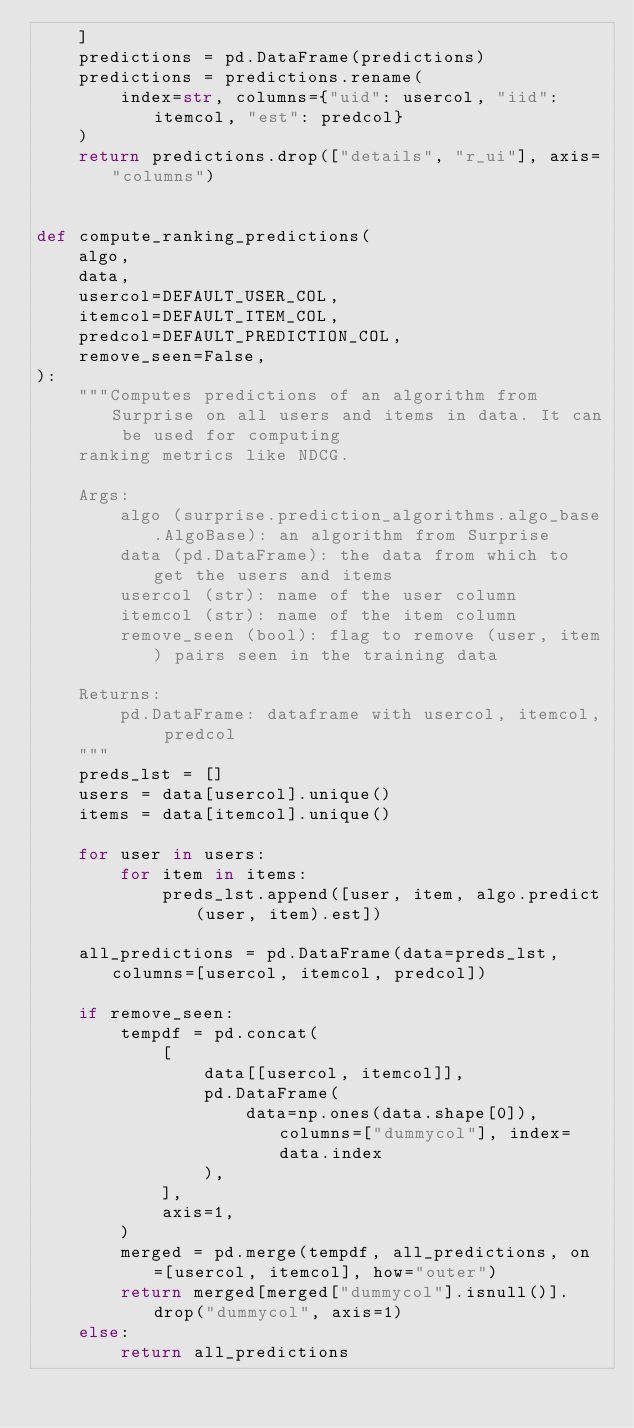Convert code to text. <code><loc_0><loc_0><loc_500><loc_500><_Python_>    ]
    predictions = pd.DataFrame(predictions)
    predictions = predictions.rename(
        index=str, columns={"uid": usercol, "iid": itemcol, "est": predcol}
    )
    return predictions.drop(["details", "r_ui"], axis="columns")


def compute_ranking_predictions(
    algo,
    data,
    usercol=DEFAULT_USER_COL,
    itemcol=DEFAULT_ITEM_COL,
    predcol=DEFAULT_PREDICTION_COL,
    remove_seen=False,
):
    """Computes predictions of an algorithm from Surprise on all users and items in data. It can be used for computing
    ranking metrics like NDCG.
    
    Args:
        algo (surprise.prediction_algorithms.algo_base.AlgoBase): an algorithm from Surprise
        data (pd.DataFrame): the data from which to get the users and items
        usercol (str): name of the user column
        itemcol (str): name of the item column
        remove_seen (bool): flag to remove (user, item) pairs seen in the training data
    
    Returns:
        pd.DataFrame: dataframe with usercol, itemcol, predcol
    """
    preds_lst = []
    users = data[usercol].unique()
    items = data[itemcol].unique()

    for user in users:
        for item in items:
            preds_lst.append([user, item, algo.predict(user, item).est])

    all_predictions = pd.DataFrame(data=preds_lst, columns=[usercol, itemcol, predcol])

    if remove_seen:
        tempdf = pd.concat(
            [
                data[[usercol, itemcol]],
                pd.DataFrame(
                    data=np.ones(data.shape[0]), columns=["dummycol"], index=data.index
                ),
            ],
            axis=1,
        )
        merged = pd.merge(tempdf, all_predictions, on=[usercol, itemcol], how="outer")
        return merged[merged["dummycol"].isnull()].drop("dummycol", axis=1)
    else:
        return all_predictions
</code> 